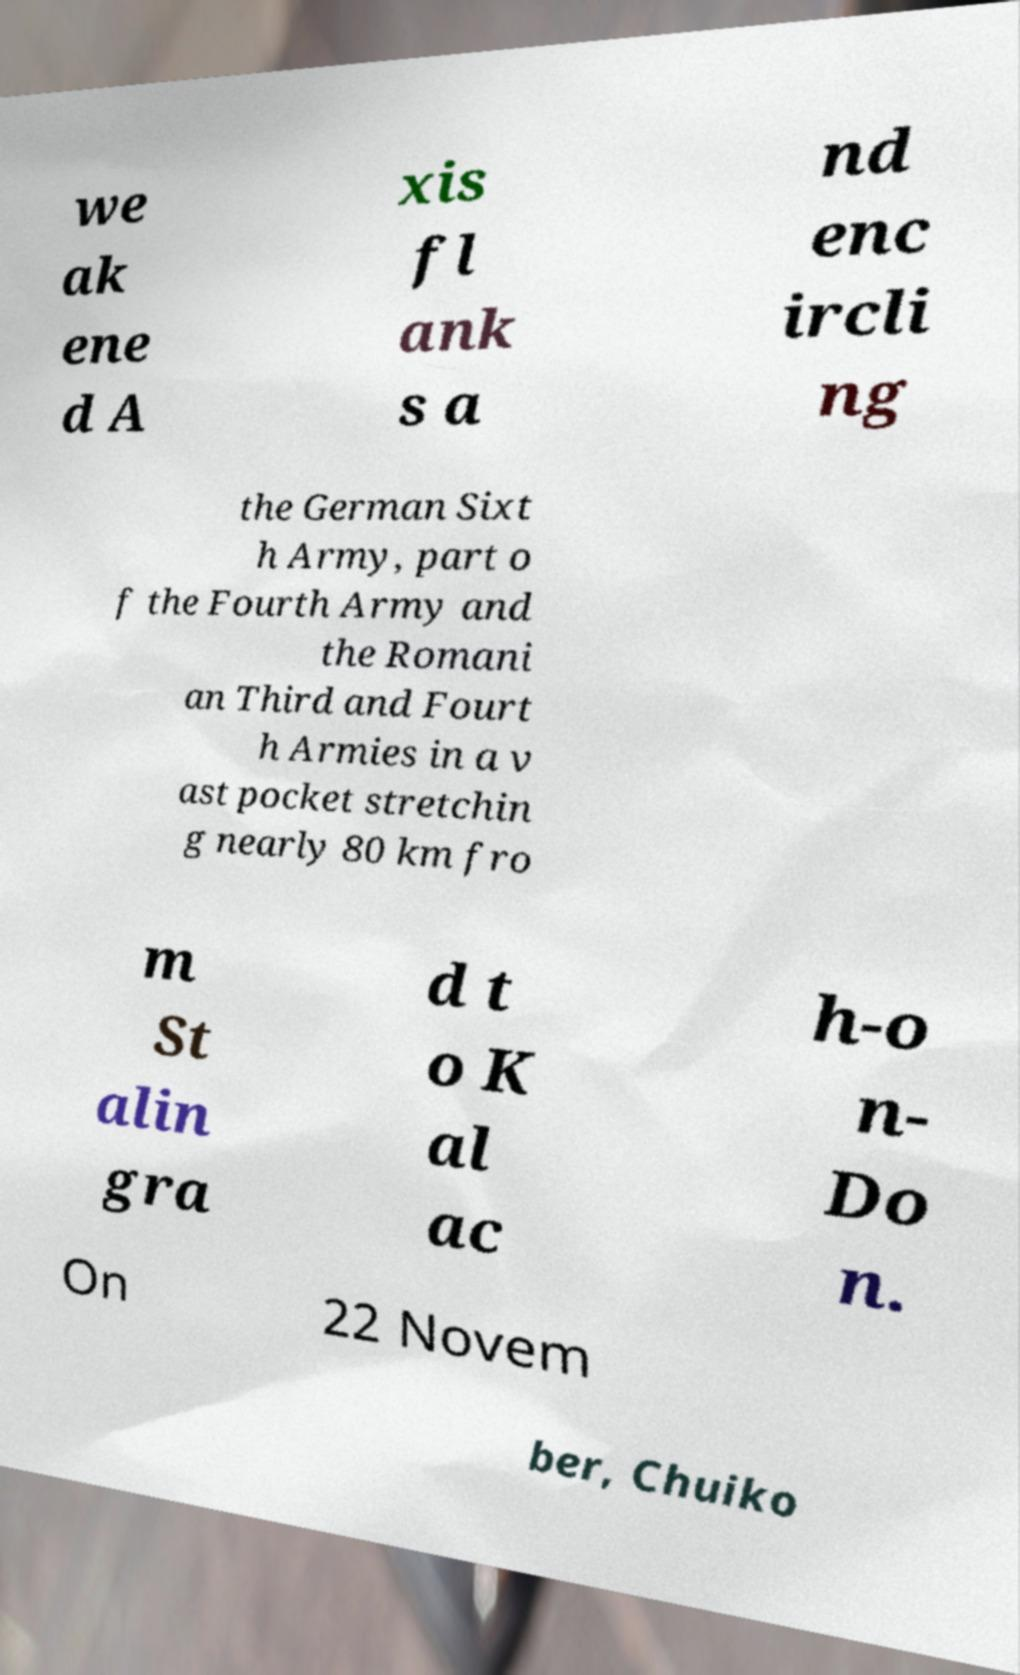Can you accurately transcribe the text from the provided image for me? we ak ene d A xis fl ank s a nd enc ircli ng the German Sixt h Army, part o f the Fourth Army and the Romani an Third and Fourt h Armies in a v ast pocket stretchin g nearly 80 km fro m St alin gra d t o K al ac h-o n- Do n. On 22 Novem ber, Chuiko 